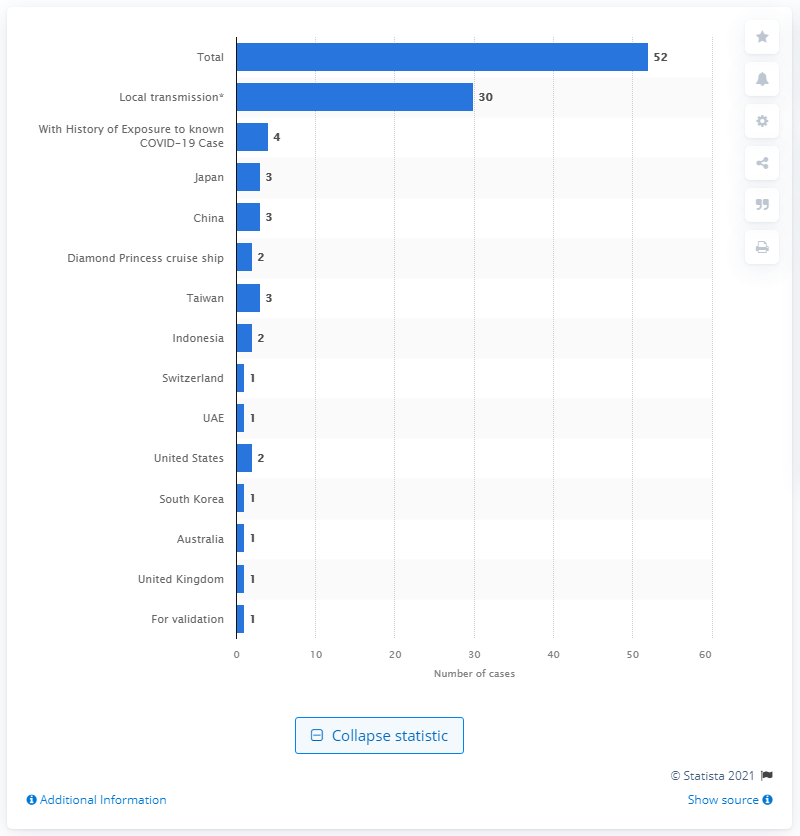List a handful of essential elements in this visual. There were 52 confirmed cases of coronavirus COVID-19 in the Philippines as of March 12, 2020. 